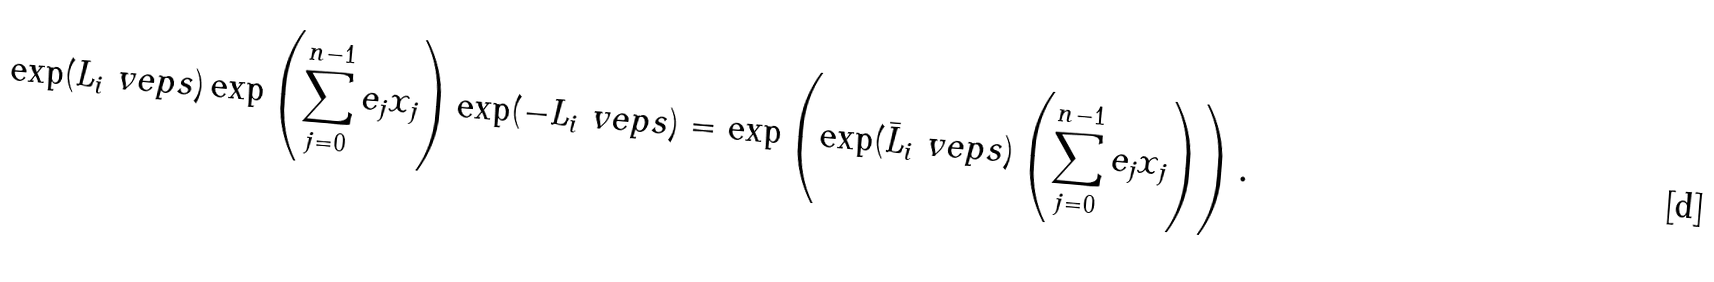<formula> <loc_0><loc_0><loc_500><loc_500>\exp ( L _ { i } \ v e p s ) \exp \left ( \sum _ { j = 0 } ^ { n - 1 } e _ { j } x _ { j } \right ) \exp ( - L _ { i } \ v e p s ) = \exp \left ( \exp ( \bar { L } _ { i } \ v e p s ) \left ( \sum _ { j = 0 } ^ { n - 1 } e _ { j } x _ { j } \right ) \right ) .</formula> 